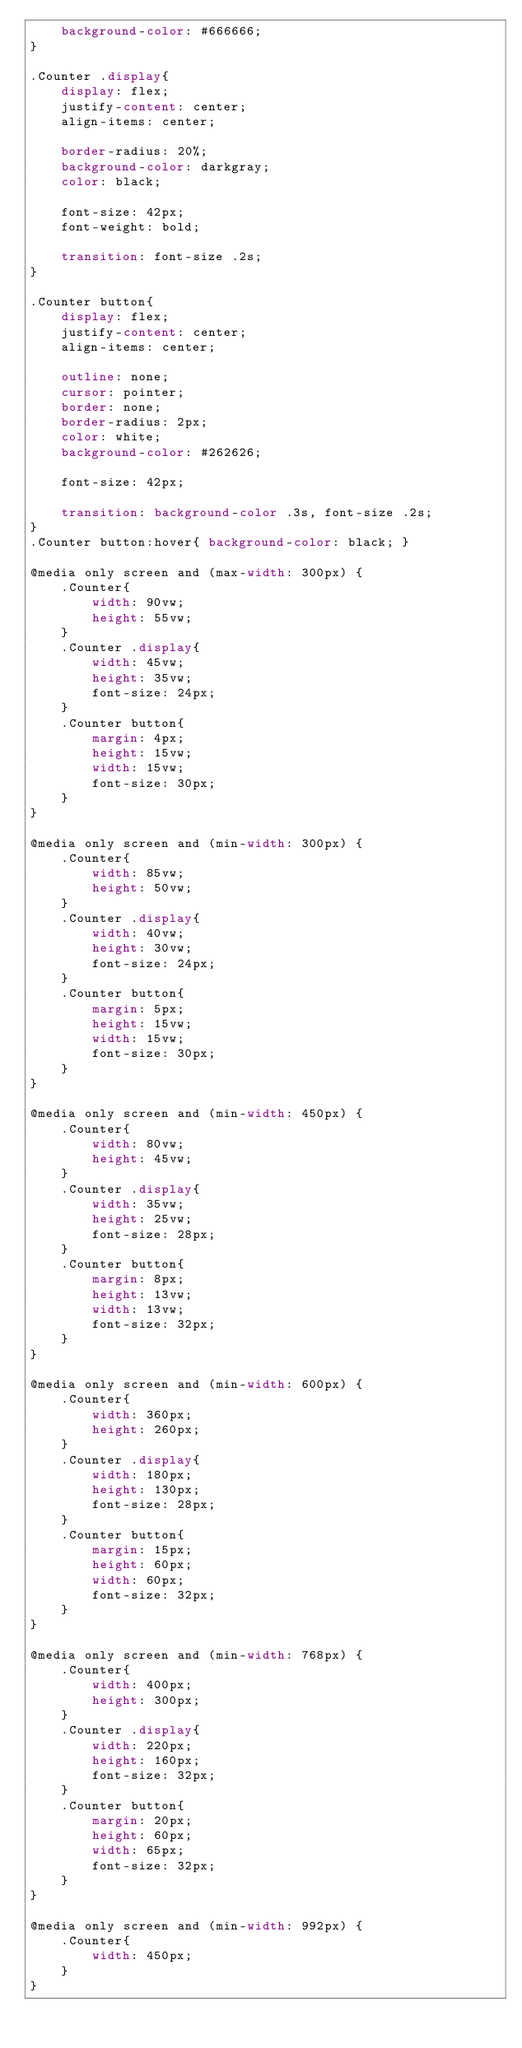<code> <loc_0><loc_0><loc_500><loc_500><_CSS_>    background-color: #666666;
}

.Counter .display{
    display: flex;
    justify-content: center;
    align-items: center;

    border-radius: 20%;
    background-color: darkgray;
    color: black;

    font-size: 42px;
    font-weight: bold;

    transition: font-size .2s;
}

.Counter button{
    display: flex;
    justify-content: center;
    align-items: center;

    outline: none;
    cursor: pointer;
    border: none;
    border-radius: 2px;
    color: white;
    background-color: #262626;

    font-size: 42px;

    transition: background-color .3s, font-size .2s;
}
.Counter button:hover{ background-color: black; }

@media only screen and (max-width: 300px) {
    .Counter{
        width: 90vw;
        height: 55vw;
    }
    .Counter .display{
        width: 45vw;
        height: 35vw;
        font-size: 24px;
    }
    .Counter button{
        margin: 4px;
        height: 15vw;
        width: 15vw;
        font-size: 30px;
    }
}

@media only screen and (min-width: 300px) {
    .Counter{
        width: 85vw;
        height: 50vw;
    }
    .Counter .display{
        width: 40vw;
        height: 30vw;
        font-size: 24px;
    }
    .Counter button{
        margin: 5px;
        height: 15vw;
        width: 15vw;
        font-size: 30px;
    }
}

@media only screen and (min-width: 450px) {
    .Counter{
        width: 80vw;
        height: 45vw;
    }
    .Counter .display{
        width: 35vw;
        height: 25vw;
        font-size: 28px;
    }
    .Counter button{
        margin: 8px;
        height: 13vw;
        width: 13vw;
        font-size: 32px;
    }
}

@media only screen and (min-width: 600px) {
    .Counter{
        width: 360px;
        height: 260px;
    }
    .Counter .display{
        width: 180px;
        height: 130px;
        font-size: 28px;
    }
    .Counter button{
        margin: 15px;
        height: 60px;
        width: 60px;
        font-size: 32px;
    }
}

@media only screen and (min-width: 768px) {
    .Counter{
        width: 400px;
        height: 300px;
    }
    .Counter .display{
        width: 220px;
        height: 160px;
        font-size: 32px;
    }
    .Counter button{
        margin: 20px;
        height: 60px;
        width: 65px;
        font-size: 32px;
    }
}

@media only screen and (min-width: 992px) {
    .Counter{
        width: 450px;
    }
}</code> 